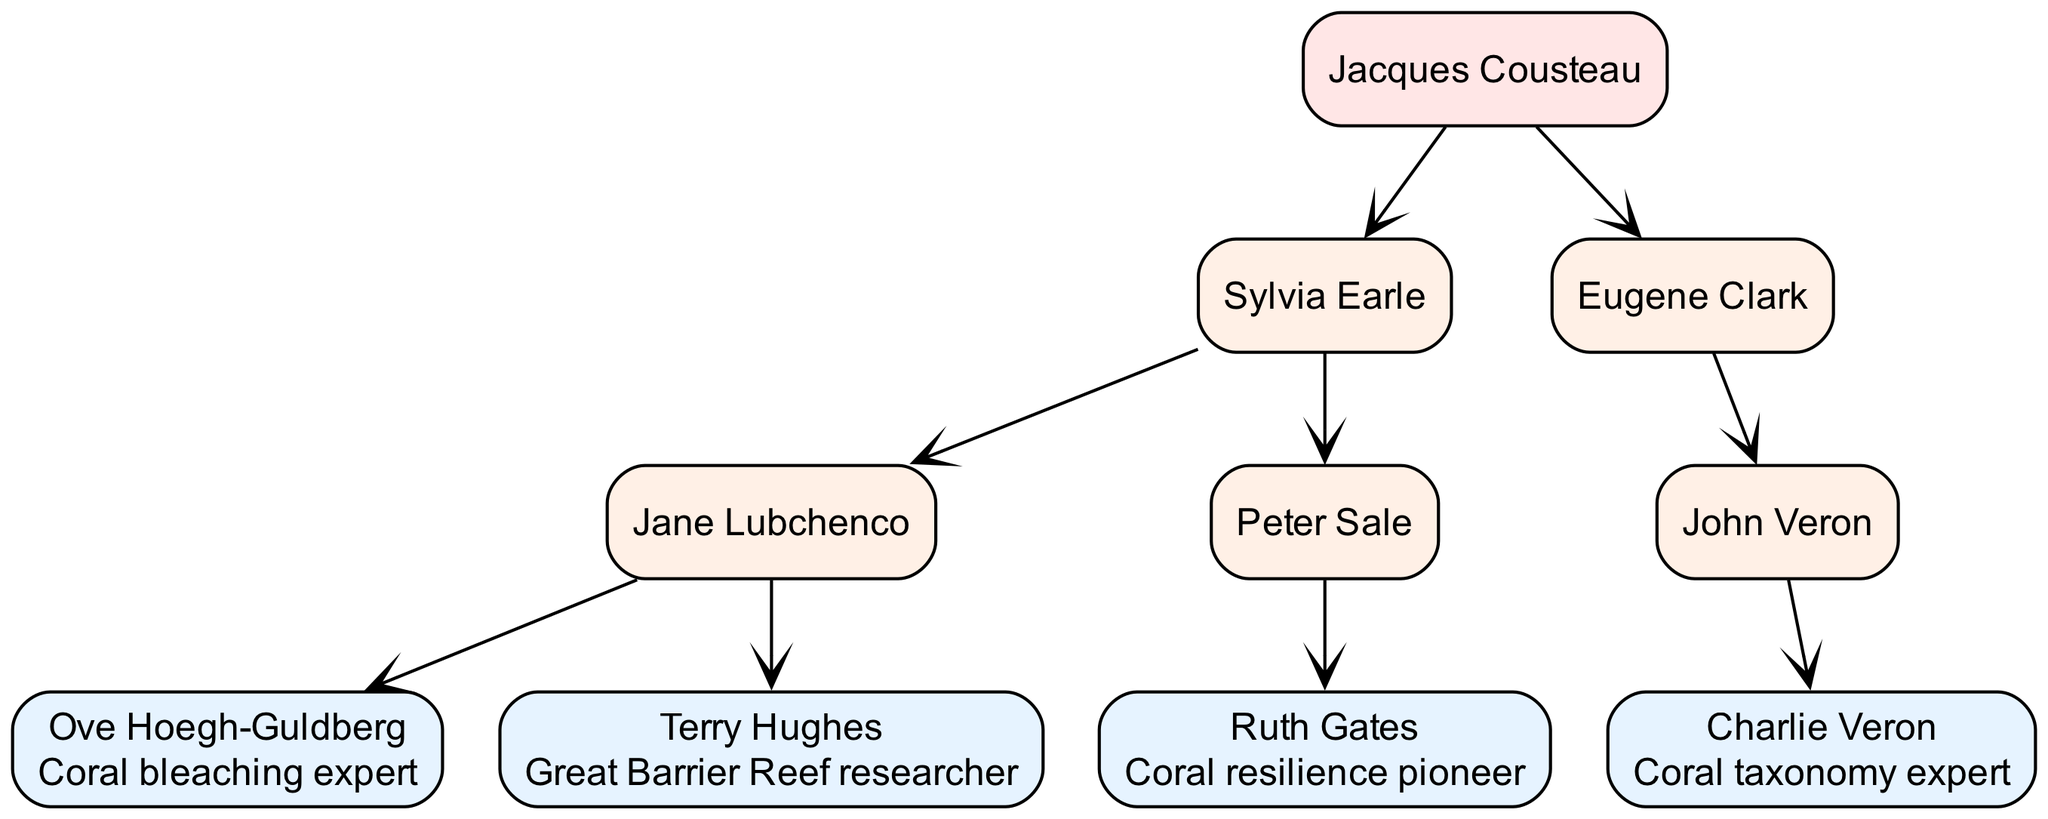What is the name of the root node in the family tree? The root node, which is at the top of the hierarchy, is Jacques Cousteau.
Answer: Jacques Cousteau How many children does Sylvia Earle have? Sylvia Earle has two children in this family tree: Jane Lubchenco and Peter Sale.
Answer: 2 Who studied under Eugene Clark? John Veron is the child of Eugene Clark, making him a direct academic descendant.
Answer: John Veron What specialty does Ruth Gates hold? The diagram indicates that Ruth Gates is a pioneer in coral resilience, which is written beside her name.
Answer: Coral resilience pioneer Which academic descendant of Sylvia Earle specializes in coral bleaching? Ove Hoegh-Guldberg is indicated as a coral bleaching expert, and he is a descendant of Sylvia Earle through Jane Lubchenco.
Answer: Ove Hoegh-Guldberg Who is the direct descendant of John Veron? Charlie Veron is identified as the direct descendant of John Veron in the lineage.
Answer: Charlie Veron How many specialties are listed in the diagram? The diagram lists five specialties: Coral bleaching expert, Great Barrier Reef researcher, Coral resilience pioneer, and Coral taxonomy expert, as well as Ruth Gates' specialty as a pioneer.
Answer: 4 Which two researchers focus specifically on coral ecosystems? Ove Hoegh-Guldberg and Terry Hughes are both recognized for their emphasis on coral ecosystems, making them key figures in coral research.
Answer: Ove Hoegh-Guldberg and Terry Hughes What is the relationship between Jacques Cousteau and Sylvia Earle? Jacques Cousteau is the mentor of Sylvia Earle, making her one of his academic descendants in the lineage of marine biology mentors.
Answer: Mentor-mentee relationship 